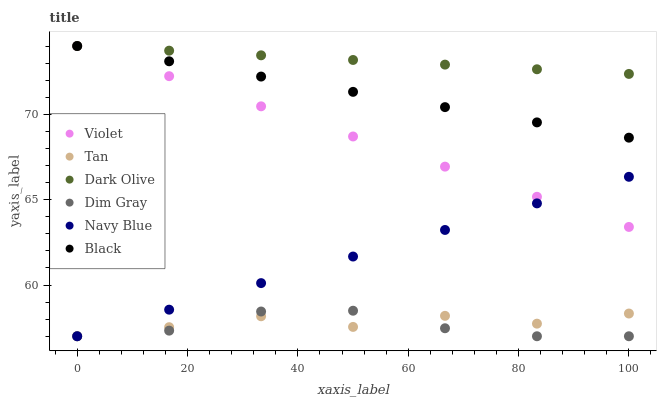Does Dim Gray have the minimum area under the curve?
Answer yes or no. Yes. Does Dark Olive have the maximum area under the curve?
Answer yes or no. Yes. Does Navy Blue have the minimum area under the curve?
Answer yes or no. No. Does Navy Blue have the maximum area under the curve?
Answer yes or no. No. Is Violet the smoothest?
Answer yes or no. Yes. Is Tan the roughest?
Answer yes or no. Yes. Is Navy Blue the smoothest?
Answer yes or no. No. Is Navy Blue the roughest?
Answer yes or no. No. Does Dim Gray have the lowest value?
Answer yes or no. Yes. Does Dark Olive have the lowest value?
Answer yes or no. No. Does Violet have the highest value?
Answer yes or no. Yes. Does Navy Blue have the highest value?
Answer yes or no. No. Is Dim Gray less than Dark Olive?
Answer yes or no. Yes. Is Black greater than Dim Gray?
Answer yes or no. Yes. Does Dark Olive intersect Black?
Answer yes or no. Yes. Is Dark Olive less than Black?
Answer yes or no. No. Is Dark Olive greater than Black?
Answer yes or no. No. Does Dim Gray intersect Dark Olive?
Answer yes or no. No. 